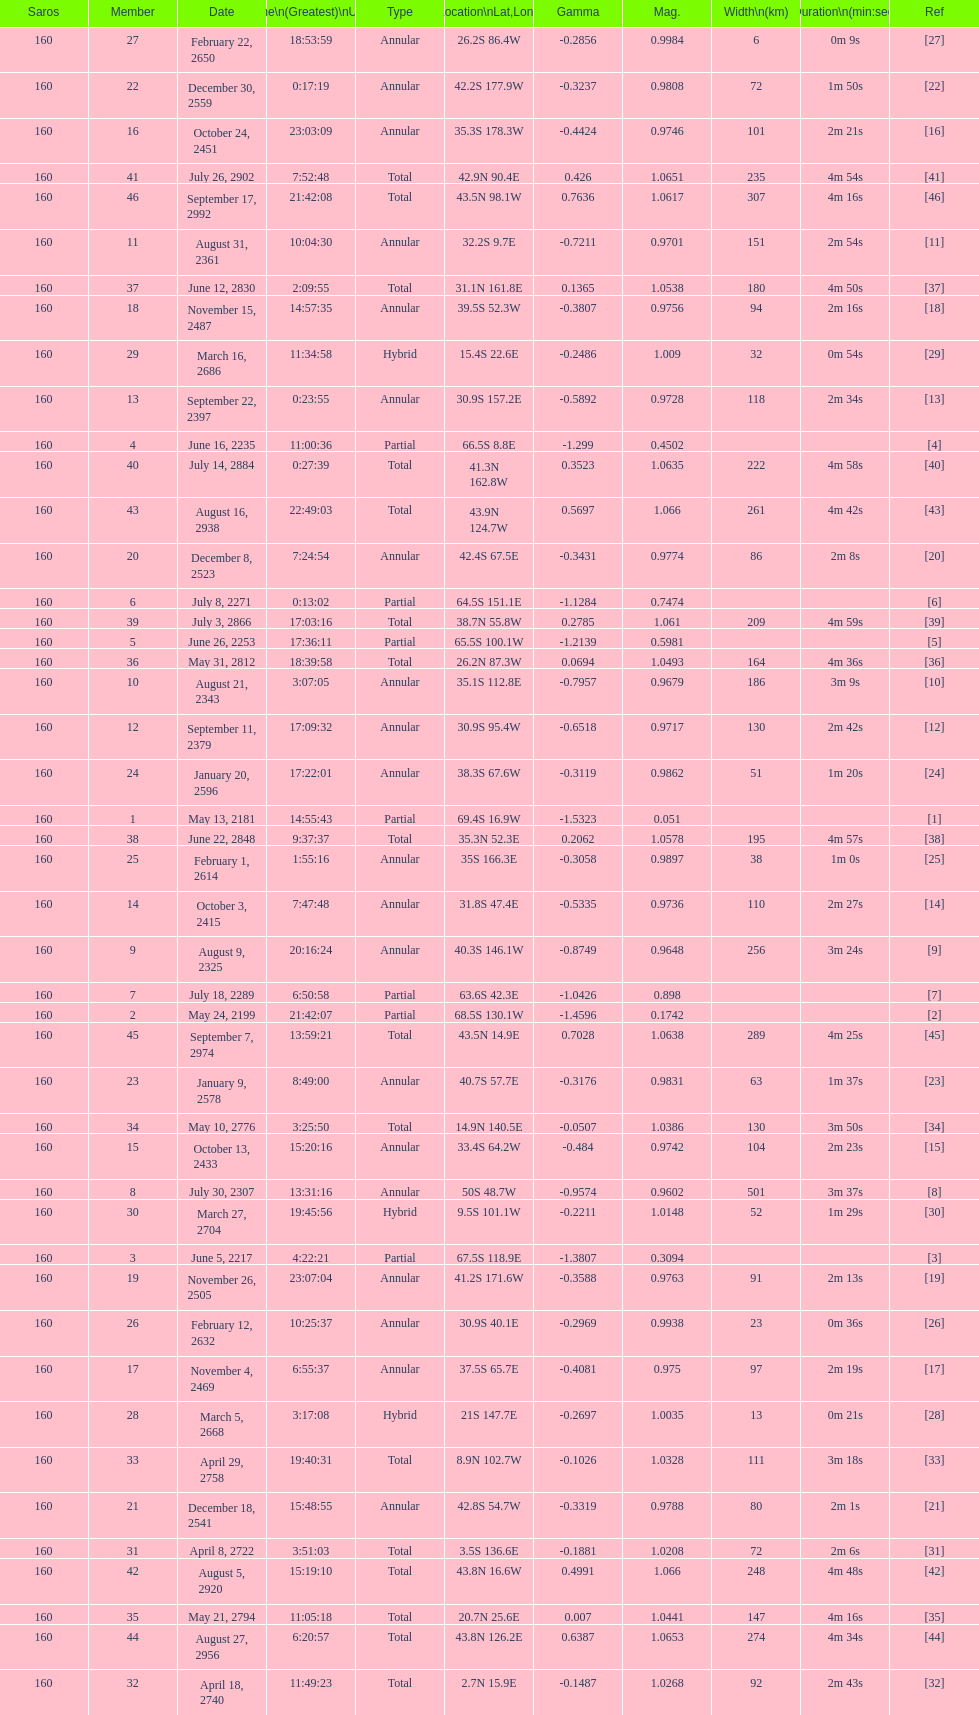When did the first solar saros with a magnitude of greater than 1.00 occur? March 5, 2668. 